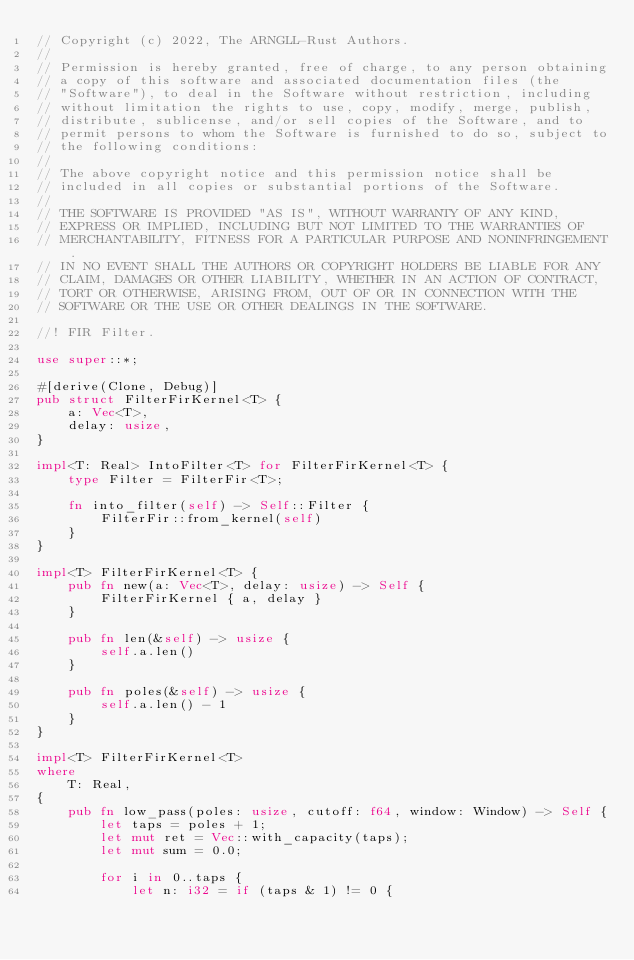<code> <loc_0><loc_0><loc_500><loc_500><_Rust_>// Copyright (c) 2022, The ARNGLL-Rust Authors.
//
// Permission is hereby granted, free of charge, to any person obtaining
// a copy of this software and associated documentation files (the
// "Software"), to deal in the Software without restriction, including
// without limitation the rights to use, copy, modify, merge, publish,
// distribute, sublicense, and/or sell copies of the Software, and to
// permit persons to whom the Software is furnished to do so, subject to
// the following conditions:
//
// The above copyright notice and this permission notice shall be
// included in all copies or substantial portions of the Software.
//
// THE SOFTWARE IS PROVIDED "AS IS", WITHOUT WARRANTY OF ANY KIND,
// EXPRESS OR IMPLIED, INCLUDING BUT NOT LIMITED TO THE WARRANTIES OF
// MERCHANTABILITY, FITNESS FOR A PARTICULAR PURPOSE AND NONINFRINGEMENT.
// IN NO EVENT SHALL THE AUTHORS OR COPYRIGHT HOLDERS BE LIABLE FOR ANY
// CLAIM, DAMAGES OR OTHER LIABILITY, WHETHER IN AN ACTION OF CONTRACT,
// TORT OR OTHERWISE, ARISING FROM, OUT OF OR IN CONNECTION WITH THE
// SOFTWARE OR THE USE OR OTHER DEALINGS IN THE SOFTWARE.

//! FIR Filter.

use super::*;

#[derive(Clone, Debug)]
pub struct FilterFirKernel<T> {
    a: Vec<T>,
    delay: usize,
}

impl<T: Real> IntoFilter<T> for FilterFirKernel<T> {
    type Filter = FilterFir<T>;

    fn into_filter(self) -> Self::Filter {
        FilterFir::from_kernel(self)
    }
}

impl<T> FilterFirKernel<T> {
    pub fn new(a: Vec<T>, delay: usize) -> Self {
        FilterFirKernel { a, delay }
    }

    pub fn len(&self) -> usize {
        self.a.len()
    }

    pub fn poles(&self) -> usize {
        self.a.len() - 1
    }
}

impl<T> FilterFirKernel<T>
where
    T: Real,
{
    pub fn low_pass(poles: usize, cutoff: f64, window: Window) -> Self {
        let taps = poles + 1;
        let mut ret = Vec::with_capacity(taps);
        let mut sum = 0.0;

        for i in 0..taps {
            let n: i32 = if (taps & 1) != 0 {</code> 